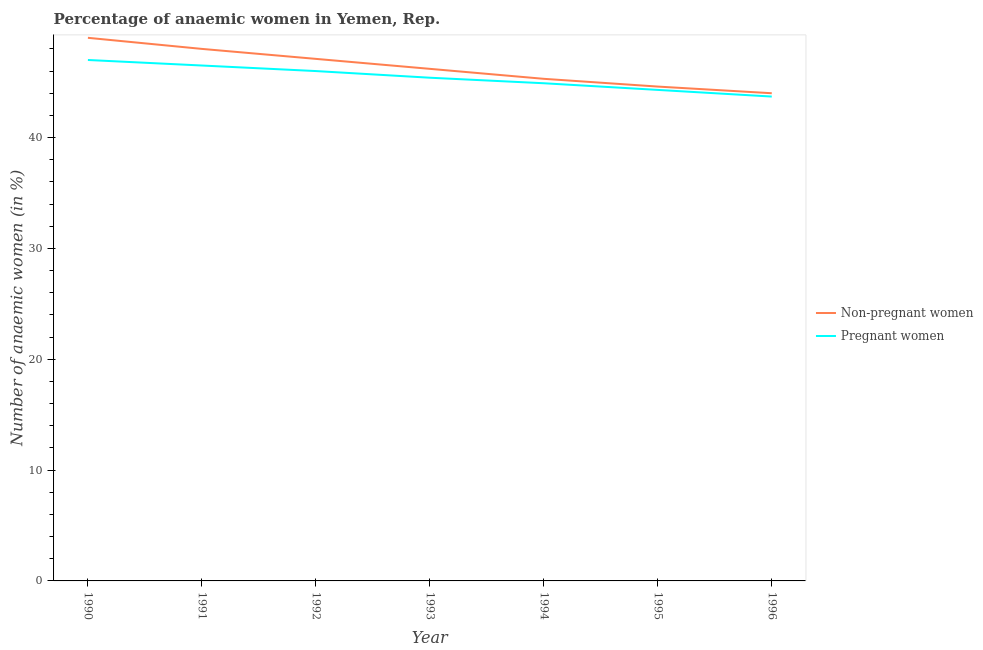How many different coloured lines are there?
Offer a terse response. 2. Is the number of lines equal to the number of legend labels?
Make the answer very short. Yes. What is the percentage of pregnant anaemic women in 1991?
Your answer should be compact. 46.5. Across all years, what is the maximum percentage of pregnant anaemic women?
Your response must be concise. 47. Across all years, what is the minimum percentage of non-pregnant anaemic women?
Provide a short and direct response. 44. What is the total percentage of non-pregnant anaemic women in the graph?
Your answer should be compact. 324.2. What is the difference between the percentage of pregnant anaemic women in 1992 and that in 1995?
Provide a succinct answer. 1.7. What is the difference between the percentage of non-pregnant anaemic women in 1993 and the percentage of pregnant anaemic women in 1995?
Make the answer very short. 1.9. What is the average percentage of non-pregnant anaemic women per year?
Provide a short and direct response. 46.31. In the year 1992, what is the difference between the percentage of non-pregnant anaemic women and percentage of pregnant anaemic women?
Keep it short and to the point. 1.1. What is the ratio of the percentage of pregnant anaemic women in 1991 to that in 1992?
Offer a very short reply. 1.01. Is the percentage of pregnant anaemic women in 1995 less than that in 1996?
Make the answer very short. No. What is the difference between the highest and the lowest percentage of pregnant anaemic women?
Make the answer very short. 3.3. Is the sum of the percentage of pregnant anaemic women in 1993 and 1995 greater than the maximum percentage of non-pregnant anaemic women across all years?
Provide a succinct answer. Yes. Is the percentage of non-pregnant anaemic women strictly less than the percentage of pregnant anaemic women over the years?
Provide a short and direct response. No. How many lines are there?
Your response must be concise. 2. How many years are there in the graph?
Give a very brief answer. 7. Does the graph contain any zero values?
Give a very brief answer. No. How are the legend labels stacked?
Offer a very short reply. Vertical. What is the title of the graph?
Your answer should be very brief. Percentage of anaemic women in Yemen, Rep. Does "RDB concessional" appear as one of the legend labels in the graph?
Give a very brief answer. No. What is the label or title of the X-axis?
Your response must be concise. Year. What is the label or title of the Y-axis?
Ensure brevity in your answer.  Number of anaemic women (in %). What is the Number of anaemic women (in %) in Non-pregnant women in 1991?
Offer a very short reply. 48. What is the Number of anaemic women (in %) of Pregnant women in 1991?
Provide a succinct answer. 46.5. What is the Number of anaemic women (in %) in Non-pregnant women in 1992?
Your response must be concise. 47.1. What is the Number of anaemic women (in %) in Pregnant women in 1992?
Give a very brief answer. 46. What is the Number of anaemic women (in %) of Non-pregnant women in 1993?
Provide a succinct answer. 46.2. What is the Number of anaemic women (in %) in Pregnant women in 1993?
Provide a short and direct response. 45.4. What is the Number of anaemic women (in %) of Non-pregnant women in 1994?
Your answer should be very brief. 45.3. What is the Number of anaemic women (in %) of Pregnant women in 1994?
Make the answer very short. 44.9. What is the Number of anaemic women (in %) in Non-pregnant women in 1995?
Your response must be concise. 44.6. What is the Number of anaemic women (in %) in Pregnant women in 1995?
Provide a short and direct response. 44.3. What is the Number of anaemic women (in %) of Non-pregnant women in 1996?
Offer a terse response. 44. What is the Number of anaemic women (in %) in Pregnant women in 1996?
Keep it short and to the point. 43.7. Across all years, what is the maximum Number of anaemic women (in %) in Non-pregnant women?
Keep it short and to the point. 49. Across all years, what is the maximum Number of anaemic women (in %) in Pregnant women?
Provide a succinct answer. 47. Across all years, what is the minimum Number of anaemic women (in %) in Pregnant women?
Your response must be concise. 43.7. What is the total Number of anaemic women (in %) of Non-pregnant women in the graph?
Provide a short and direct response. 324.2. What is the total Number of anaemic women (in %) of Pregnant women in the graph?
Ensure brevity in your answer.  317.8. What is the difference between the Number of anaemic women (in %) of Non-pregnant women in 1990 and that in 1992?
Provide a short and direct response. 1.9. What is the difference between the Number of anaemic women (in %) of Pregnant women in 1990 and that in 1992?
Provide a short and direct response. 1. What is the difference between the Number of anaemic women (in %) in Non-pregnant women in 1990 and that in 1994?
Give a very brief answer. 3.7. What is the difference between the Number of anaemic women (in %) in Pregnant women in 1990 and that in 1994?
Offer a very short reply. 2.1. What is the difference between the Number of anaemic women (in %) of Non-pregnant women in 1990 and that in 1995?
Provide a short and direct response. 4.4. What is the difference between the Number of anaemic women (in %) of Pregnant women in 1991 and that in 1992?
Your response must be concise. 0.5. What is the difference between the Number of anaemic women (in %) of Pregnant women in 1991 and that in 1993?
Provide a succinct answer. 1.1. What is the difference between the Number of anaemic women (in %) of Pregnant women in 1991 and that in 1996?
Ensure brevity in your answer.  2.8. What is the difference between the Number of anaemic women (in %) of Pregnant women in 1992 and that in 1994?
Your response must be concise. 1.1. What is the difference between the Number of anaemic women (in %) in Pregnant women in 1992 and that in 1995?
Offer a very short reply. 1.7. What is the difference between the Number of anaemic women (in %) of Non-pregnant women in 1992 and that in 1996?
Provide a short and direct response. 3.1. What is the difference between the Number of anaemic women (in %) in Non-pregnant women in 1993 and that in 1994?
Your response must be concise. 0.9. What is the difference between the Number of anaemic women (in %) in Non-pregnant women in 1993 and that in 1995?
Offer a terse response. 1.6. What is the difference between the Number of anaemic women (in %) in Pregnant women in 1993 and that in 1995?
Give a very brief answer. 1.1. What is the difference between the Number of anaemic women (in %) of Non-pregnant women in 1993 and that in 1996?
Offer a very short reply. 2.2. What is the difference between the Number of anaemic women (in %) of Pregnant women in 1993 and that in 1996?
Make the answer very short. 1.7. What is the difference between the Number of anaemic women (in %) in Pregnant women in 1994 and that in 1996?
Provide a short and direct response. 1.2. What is the difference between the Number of anaemic women (in %) in Pregnant women in 1995 and that in 1996?
Give a very brief answer. 0.6. What is the difference between the Number of anaemic women (in %) in Non-pregnant women in 1990 and the Number of anaemic women (in %) in Pregnant women in 1991?
Offer a very short reply. 2.5. What is the difference between the Number of anaemic women (in %) in Non-pregnant women in 1990 and the Number of anaemic women (in %) in Pregnant women in 1994?
Offer a very short reply. 4.1. What is the difference between the Number of anaemic women (in %) of Non-pregnant women in 1990 and the Number of anaemic women (in %) of Pregnant women in 1995?
Provide a short and direct response. 4.7. What is the difference between the Number of anaemic women (in %) in Non-pregnant women in 1990 and the Number of anaemic women (in %) in Pregnant women in 1996?
Make the answer very short. 5.3. What is the difference between the Number of anaemic women (in %) in Non-pregnant women in 1991 and the Number of anaemic women (in %) in Pregnant women in 1992?
Keep it short and to the point. 2. What is the difference between the Number of anaemic women (in %) of Non-pregnant women in 1991 and the Number of anaemic women (in %) of Pregnant women in 1993?
Ensure brevity in your answer.  2.6. What is the difference between the Number of anaemic women (in %) in Non-pregnant women in 1991 and the Number of anaemic women (in %) in Pregnant women in 1995?
Provide a short and direct response. 3.7. What is the difference between the Number of anaemic women (in %) in Non-pregnant women in 1991 and the Number of anaemic women (in %) in Pregnant women in 1996?
Ensure brevity in your answer.  4.3. What is the difference between the Number of anaemic women (in %) of Non-pregnant women in 1992 and the Number of anaemic women (in %) of Pregnant women in 1993?
Your answer should be very brief. 1.7. What is the difference between the Number of anaemic women (in %) in Non-pregnant women in 1992 and the Number of anaemic women (in %) in Pregnant women in 1994?
Your response must be concise. 2.2. What is the difference between the Number of anaemic women (in %) of Non-pregnant women in 1992 and the Number of anaemic women (in %) of Pregnant women in 1995?
Ensure brevity in your answer.  2.8. What is the difference between the Number of anaemic women (in %) of Non-pregnant women in 1992 and the Number of anaemic women (in %) of Pregnant women in 1996?
Ensure brevity in your answer.  3.4. What is the difference between the Number of anaemic women (in %) in Non-pregnant women in 1993 and the Number of anaemic women (in %) in Pregnant women in 1994?
Your answer should be compact. 1.3. What is the difference between the Number of anaemic women (in %) of Non-pregnant women in 1993 and the Number of anaemic women (in %) of Pregnant women in 1995?
Your answer should be very brief. 1.9. What is the difference between the Number of anaemic women (in %) of Non-pregnant women in 1994 and the Number of anaemic women (in %) of Pregnant women in 1996?
Provide a short and direct response. 1.6. What is the difference between the Number of anaemic women (in %) of Non-pregnant women in 1995 and the Number of anaemic women (in %) of Pregnant women in 1996?
Give a very brief answer. 0.9. What is the average Number of anaemic women (in %) in Non-pregnant women per year?
Your answer should be very brief. 46.31. What is the average Number of anaemic women (in %) in Pregnant women per year?
Ensure brevity in your answer.  45.4. In the year 1990, what is the difference between the Number of anaemic women (in %) in Non-pregnant women and Number of anaemic women (in %) in Pregnant women?
Offer a very short reply. 2. In the year 1995, what is the difference between the Number of anaemic women (in %) of Non-pregnant women and Number of anaemic women (in %) of Pregnant women?
Your answer should be very brief. 0.3. What is the ratio of the Number of anaemic women (in %) of Non-pregnant women in 1990 to that in 1991?
Provide a succinct answer. 1.02. What is the ratio of the Number of anaemic women (in %) in Pregnant women in 1990 to that in 1991?
Keep it short and to the point. 1.01. What is the ratio of the Number of anaemic women (in %) of Non-pregnant women in 1990 to that in 1992?
Ensure brevity in your answer.  1.04. What is the ratio of the Number of anaemic women (in %) of Pregnant women in 1990 to that in 1992?
Offer a very short reply. 1.02. What is the ratio of the Number of anaemic women (in %) in Non-pregnant women in 1990 to that in 1993?
Your answer should be compact. 1.06. What is the ratio of the Number of anaemic women (in %) in Pregnant women in 1990 to that in 1993?
Ensure brevity in your answer.  1.04. What is the ratio of the Number of anaemic women (in %) of Non-pregnant women in 1990 to that in 1994?
Ensure brevity in your answer.  1.08. What is the ratio of the Number of anaemic women (in %) in Pregnant women in 1990 to that in 1994?
Keep it short and to the point. 1.05. What is the ratio of the Number of anaemic women (in %) of Non-pregnant women in 1990 to that in 1995?
Your response must be concise. 1.1. What is the ratio of the Number of anaemic women (in %) of Pregnant women in 1990 to that in 1995?
Provide a succinct answer. 1.06. What is the ratio of the Number of anaemic women (in %) in Non-pregnant women in 1990 to that in 1996?
Your response must be concise. 1.11. What is the ratio of the Number of anaemic women (in %) in Pregnant women in 1990 to that in 1996?
Offer a terse response. 1.08. What is the ratio of the Number of anaemic women (in %) of Non-pregnant women in 1991 to that in 1992?
Keep it short and to the point. 1.02. What is the ratio of the Number of anaemic women (in %) in Pregnant women in 1991 to that in 1992?
Offer a very short reply. 1.01. What is the ratio of the Number of anaemic women (in %) of Non-pregnant women in 1991 to that in 1993?
Provide a succinct answer. 1.04. What is the ratio of the Number of anaemic women (in %) in Pregnant women in 1991 to that in 1993?
Give a very brief answer. 1.02. What is the ratio of the Number of anaemic women (in %) of Non-pregnant women in 1991 to that in 1994?
Provide a succinct answer. 1.06. What is the ratio of the Number of anaemic women (in %) in Pregnant women in 1991 to that in 1994?
Your answer should be very brief. 1.04. What is the ratio of the Number of anaemic women (in %) of Non-pregnant women in 1991 to that in 1995?
Your answer should be very brief. 1.08. What is the ratio of the Number of anaemic women (in %) in Pregnant women in 1991 to that in 1995?
Offer a terse response. 1.05. What is the ratio of the Number of anaemic women (in %) in Non-pregnant women in 1991 to that in 1996?
Your answer should be very brief. 1.09. What is the ratio of the Number of anaemic women (in %) of Pregnant women in 1991 to that in 1996?
Provide a short and direct response. 1.06. What is the ratio of the Number of anaemic women (in %) of Non-pregnant women in 1992 to that in 1993?
Offer a terse response. 1.02. What is the ratio of the Number of anaemic women (in %) in Pregnant women in 1992 to that in 1993?
Ensure brevity in your answer.  1.01. What is the ratio of the Number of anaemic women (in %) of Non-pregnant women in 1992 to that in 1994?
Keep it short and to the point. 1.04. What is the ratio of the Number of anaemic women (in %) of Pregnant women in 1992 to that in 1994?
Ensure brevity in your answer.  1.02. What is the ratio of the Number of anaemic women (in %) of Non-pregnant women in 1992 to that in 1995?
Give a very brief answer. 1.06. What is the ratio of the Number of anaemic women (in %) of Pregnant women in 1992 to that in 1995?
Ensure brevity in your answer.  1.04. What is the ratio of the Number of anaemic women (in %) of Non-pregnant women in 1992 to that in 1996?
Ensure brevity in your answer.  1.07. What is the ratio of the Number of anaemic women (in %) in Pregnant women in 1992 to that in 1996?
Your answer should be very brief. 1.05. What is the ratio of the Number of anaemic women (in %) in Non-pregnant women in 1993 to that in 1994?
Your response must be concise. 1.02. What is the ratio of the Number of anaemic women (in %) in Pregnant women in 1993 to that in 1994?
Give a very brief answer. 1.01. What is the ratio of the Number of anaemic women (in %) of Non-pregnant women in 1993 to that in 1995?
Ensure brevity in your answer.  1.04. What is the ratio of the Number of anaemic women (in %) of Pregnant women in 1993 to that in 1995?
Provide a succinct answer. 1.02. What is the ratio of the Number of anaemic women (in %) in Pregnant women in 1993 to that in 1996?
Make the answer very short. 1.04. What is the ratio of the Number of anaemic women (in %) in Non-pregnant women in 1994 to that in 1995?
Your response must be concise. 1.02. What is the ratio of the Number of anaemic women (in %) of Pregnant women in 1994 to that in 1995?
Your response must be concise. 1.01. What is the ratio of the Number of anaemic women (in %) in Non-pregnant women in 1994 to that in 1996?
Your answer should be very brief. 1.03. What is the ratio of the Number of anaemic women (in %) of Pregnant women in 1994 to that in 1996?
Keep it short and to the point. 1.03. What is the ratio of the Number of anaemic women (in %) of Non-pregnant women in 1995 to that in 1996?
Make the answer very short. 1.01. What is the ratio of the Number of anaemic women (in %) in Pregnant women in 1995 to that in 1996?
Make the answer very short. 1.01. What is the difference between the highest and the lowest Number of anaemic women (in %) in Non-pregnant women?
Offer a very short reply. 5. What is the difference between the highest and the lowest Number of anaemic women (in %) of Pregnant women?
Give a very brief answer. 3.3. 